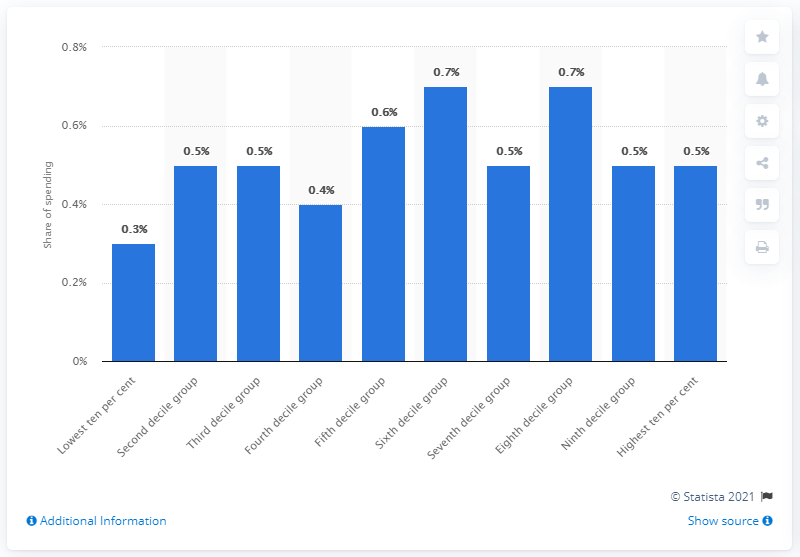Outline some significant characteristics in this image. In 2020, the average share of expenditure across all households in the UK was 0.5%. According to the data, households in the second decile group spent approximately 50% of their weekly household expenditure on games, toys, and hobbies. 